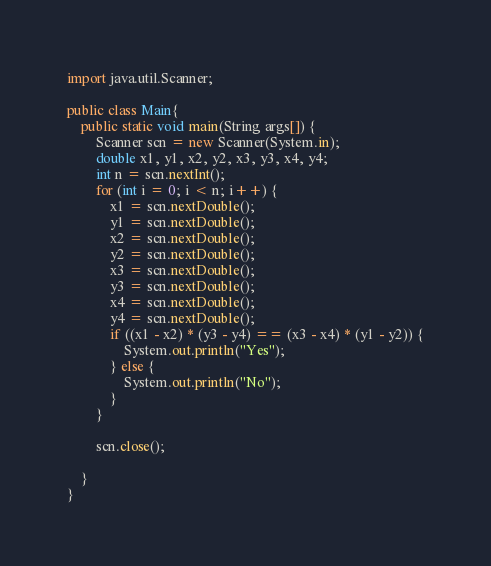<code> <loc_0><loc_0><loc_500><loc_500><_Java_>import java.util.Scanner;

public class Main{
	public static void main(String args[]) {
		Scanner scn = new Scanner(System.in);
		double x1, y1, x2, y2, x3, y3, x4, y4;
		int n = scn.nextInt();
		for (int i = 0; i < n; i++) {
			x1 = scn.nextDouble();
			y1 = scn.nextDouble();
			x2 = scn.nextDouble();
			y2 = scn.nextDouble();
			x3 = scn.nextDouble();
			y3 = scn.nextDouble();
			x4 = scn.nextDouble();
			y4 = scn.nextDouble();
			if ((x1 - x2) * (y3 - y4) == (x3 - x4) * (y1 - y2)) {
				System.out.println("Yes");
			} else {
				System.out.println("No");
			}
		}

		scn.close();

	}
}
</code> 